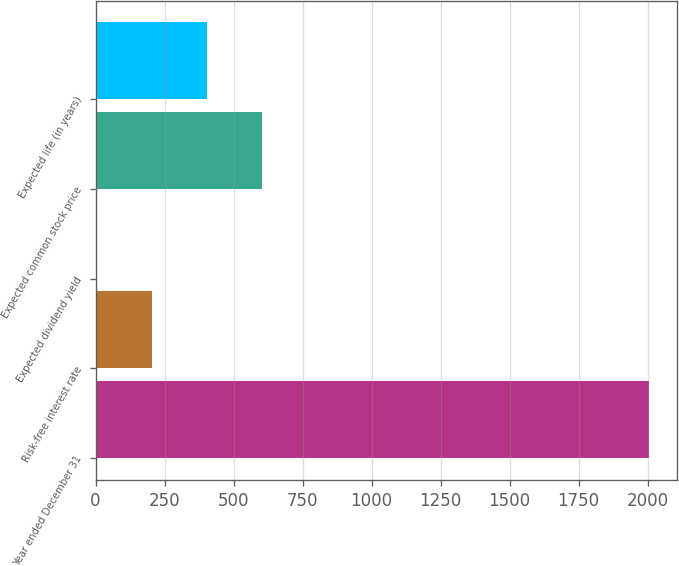Convert chart. <chart><loc_0><loc_0><loc_500><loc_500><bar_chart><fcel>Year ended December 31<fcel>Risk-free interest rate<fcel>Expected dividend yield<fcel>Expected common stock price<fcel>Expected life (in years)<nl><fcel>2007<fcel>203.56<fcel>3.18<fcel>604.32<fcel>403.94<nl></chart> 